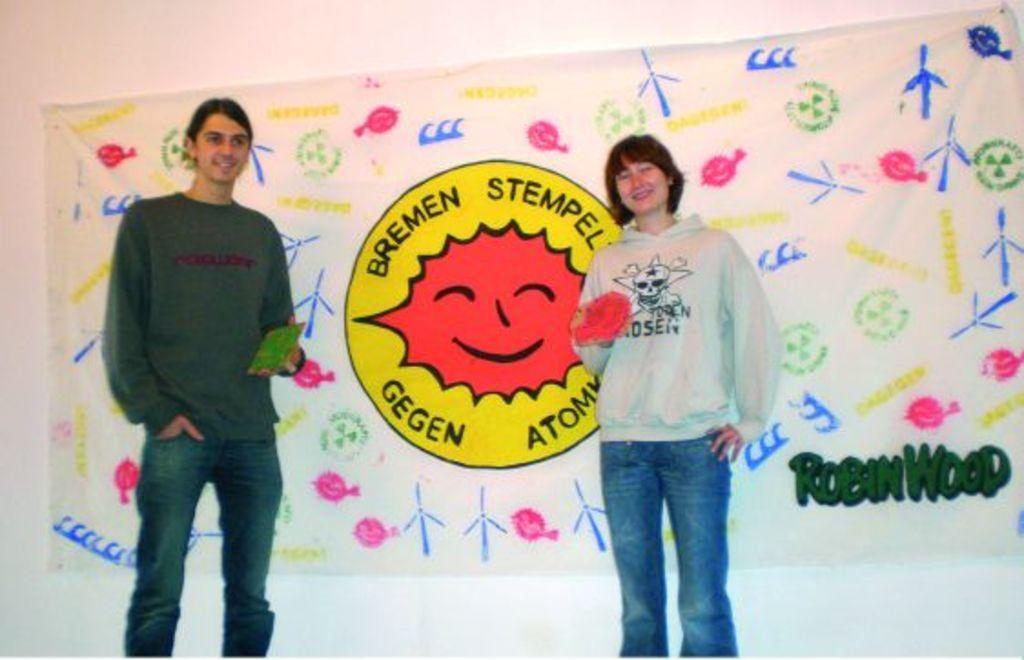How many people are in the image? There are two people in the image. What are the people doing in the image? The people are standing and holding objects. What can be seen in the background of the image? There is a banner and a wall in the background of the image. What type of meat is being covered by the veil in the image? There is no meat or veil present in the image. Can you tell me which person has the longest ear in the image? There is no mention of ears or their length in the image. 